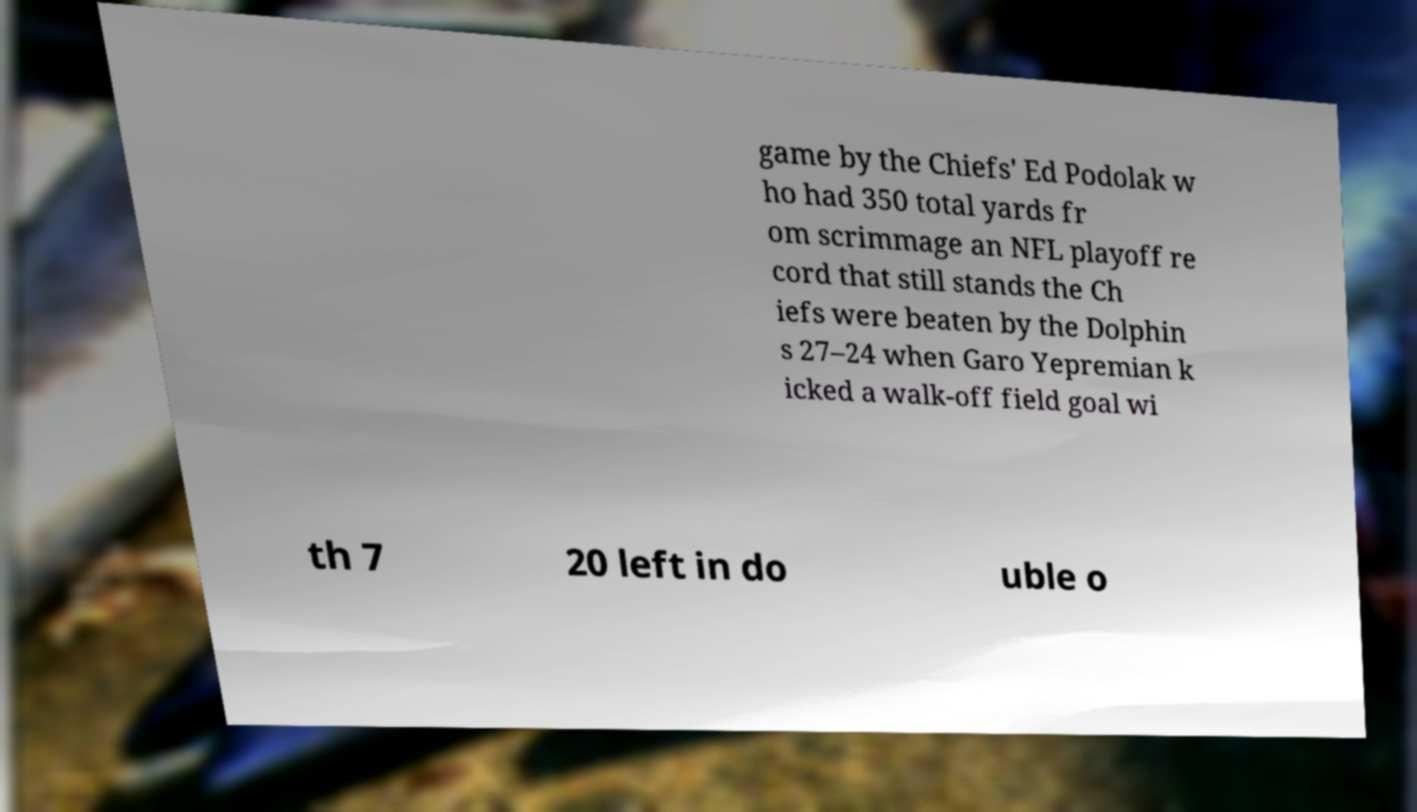There's text embedded in this image that I need extracted. Can you transcribe it verbatim? game by the Chiefs' Ed Podolak w ho had 350 total yards fr om scrimmage an NFL playoff re cord that still stands the Ch iefs were beaten by the Dolphin s 27–24 when Garo Yepremian k icked a walk-off field goal wi th 7 20 left in do uble o 